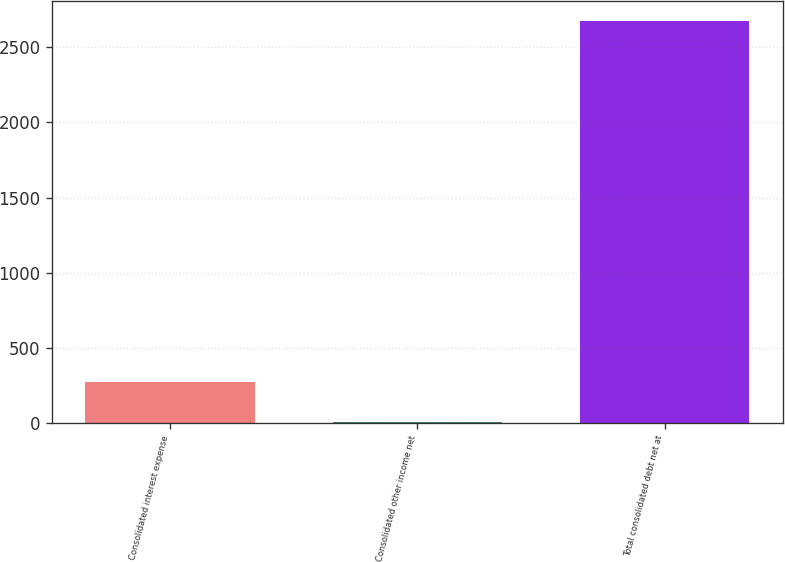<chart> <loc_0><loc_0><loc_500><loc_500><bar_chart><fcel>Consolidated interest expense<fcel>Consolidated other income net<fcel>Total consolidated debt net at<nl><fcel>269.38<fcel>2.4<fcel>2672.2<nl></chart> 